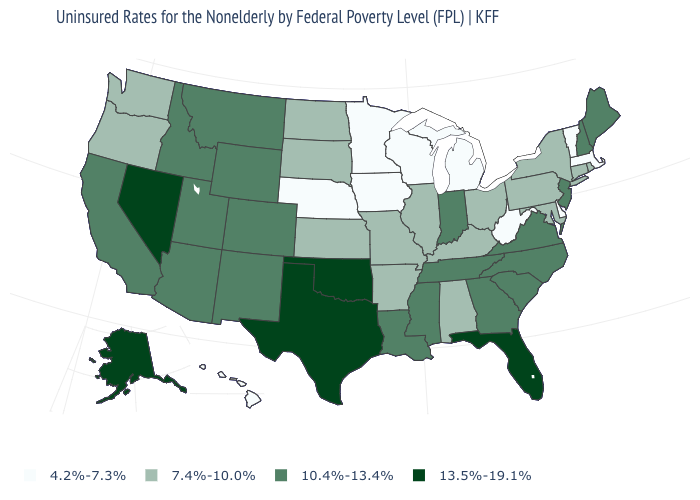Which states have the lowest value in the USA?
Short answer required. Delaware, Hawaii, Iowa, Massachusetts, Michigan, Minnesota, Nebraska, Vermont, West Virginia, Wisconsin. Does Wisconsin have the lowest value in the MidWest?
Be succinct. Yes. What is the value of Washington?
Be succinct. 7.4%-10.0%. What is the value of North Dakota?
Write a very short answer. 7.4%-10.0%. How many symbols are there in the legend?
Answer briefly. 4. Does Tennessee have a higher value than West Virginia?
Be succinct. Yes. What is the highest value in the MidWest ?
Concise answer only. 10.4%-13.4%. What is the value of New Hampshire?
Give a very brief answer. 10.4%-13.4%. What is the value of Alabama?
Give a very brief answer. 7.4%-10.0%. What is the lowest value in the USA?
Quick response, please. 4.2%-7.3%. Name the states that have a value in the range 4.2%-7.3%?
Write a very short answer. Delaware, Hawaii, Iowa, Massachusetts, Michigan, Minnesota, Nebraska, Vermont, West Virginia, Wisconsin. Which states have the lowest value in the USA?
Give a very brief answer. Delaware, Hawaii, Iowa, Massachusetts, Michigan, Minnesota, Nebraska, Vermont, West Virginia, Wisconsin. What is the lowest value in states that border Connecticut?
Write a very short answer. 4.2%-7.3%. What is the value of Montana?
Keep it brief. 10.4%-13.4%. Does Pennsylvania have the highest value in the USA?
Keep it brief. No. 